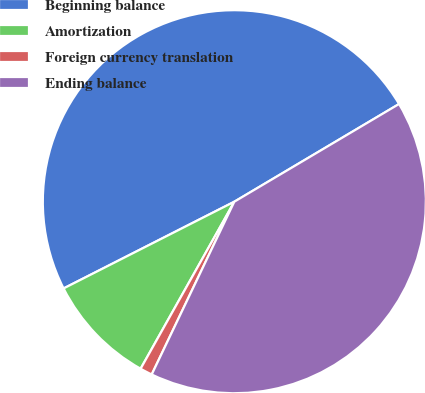Convert chart to OTSL. <chart><loc_0><loc_0><loc_500><loc_500><pie_chart><fcel>Beginning balance<fcel>Amortization<fcel>Foreign currency translation<fcel>Ending balance<nl><fcel>48.96%<fcel>9.38%<fcel>1.04%<fcel>40.62%<nl></chart> 